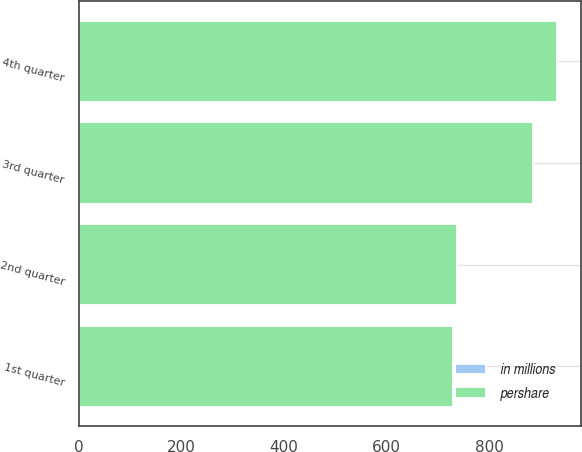<chart> <loc_0><loc_0><loc_500><loc_500><stacked_bar_chart><ecel><fcel>1st quarter<fcel>2nd quarter<fcel>3rd quarter<fcel>4th quarter<nl><fcel>pershare<fcel>728.7<fcel>736.8<fcel>884.4<fcel>929.8<nl><fcel>in millions<fcel>0.78<fcel>0.81<fcel>1.03<fcel>1.1<nl></chart> 